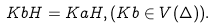<formula> <loc_0><loc_0><loc_500><loc_500>K b H = K a H , ( K b \in V ( \Delta ) ) .</formula> 